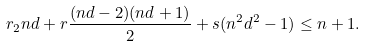Convert formula to latex. <formula><loc_0><loc_0><loc_500><loc_500>r _ { 2 } n d + r \frac { ( n d - 2 ) ( n d + 1 ) } { 2 } + s ( n ^ { 2 } d ^ { 2 } - 1 ) \leq n + 1 .</formula> 